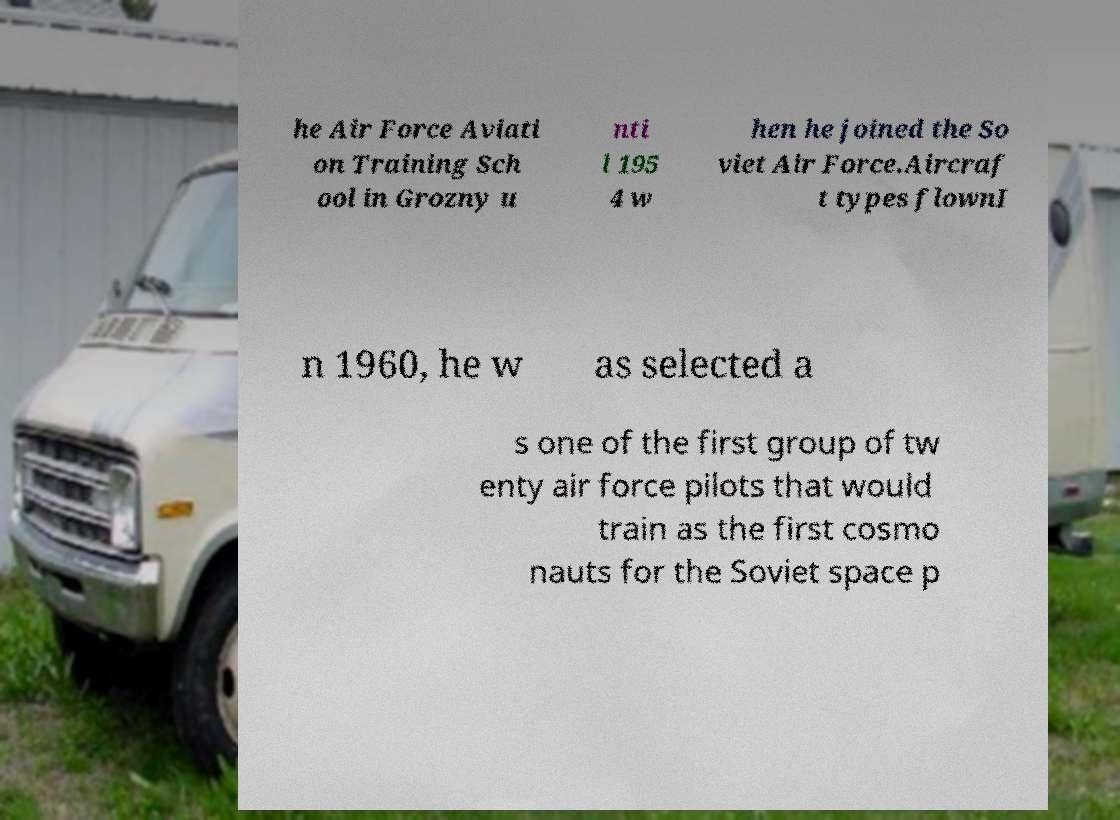Please identify and transcribe the text found in this image. he Air Force Aviati on Training Sch ool in Grozny u nti l 195 4 w hen he joined the So viet Air Force.Aircraf t types flownI n 1960, he w as selected a s one of the first group of tw enty air force pilots that would train as the first cosmo nauts for the Soviet space p 